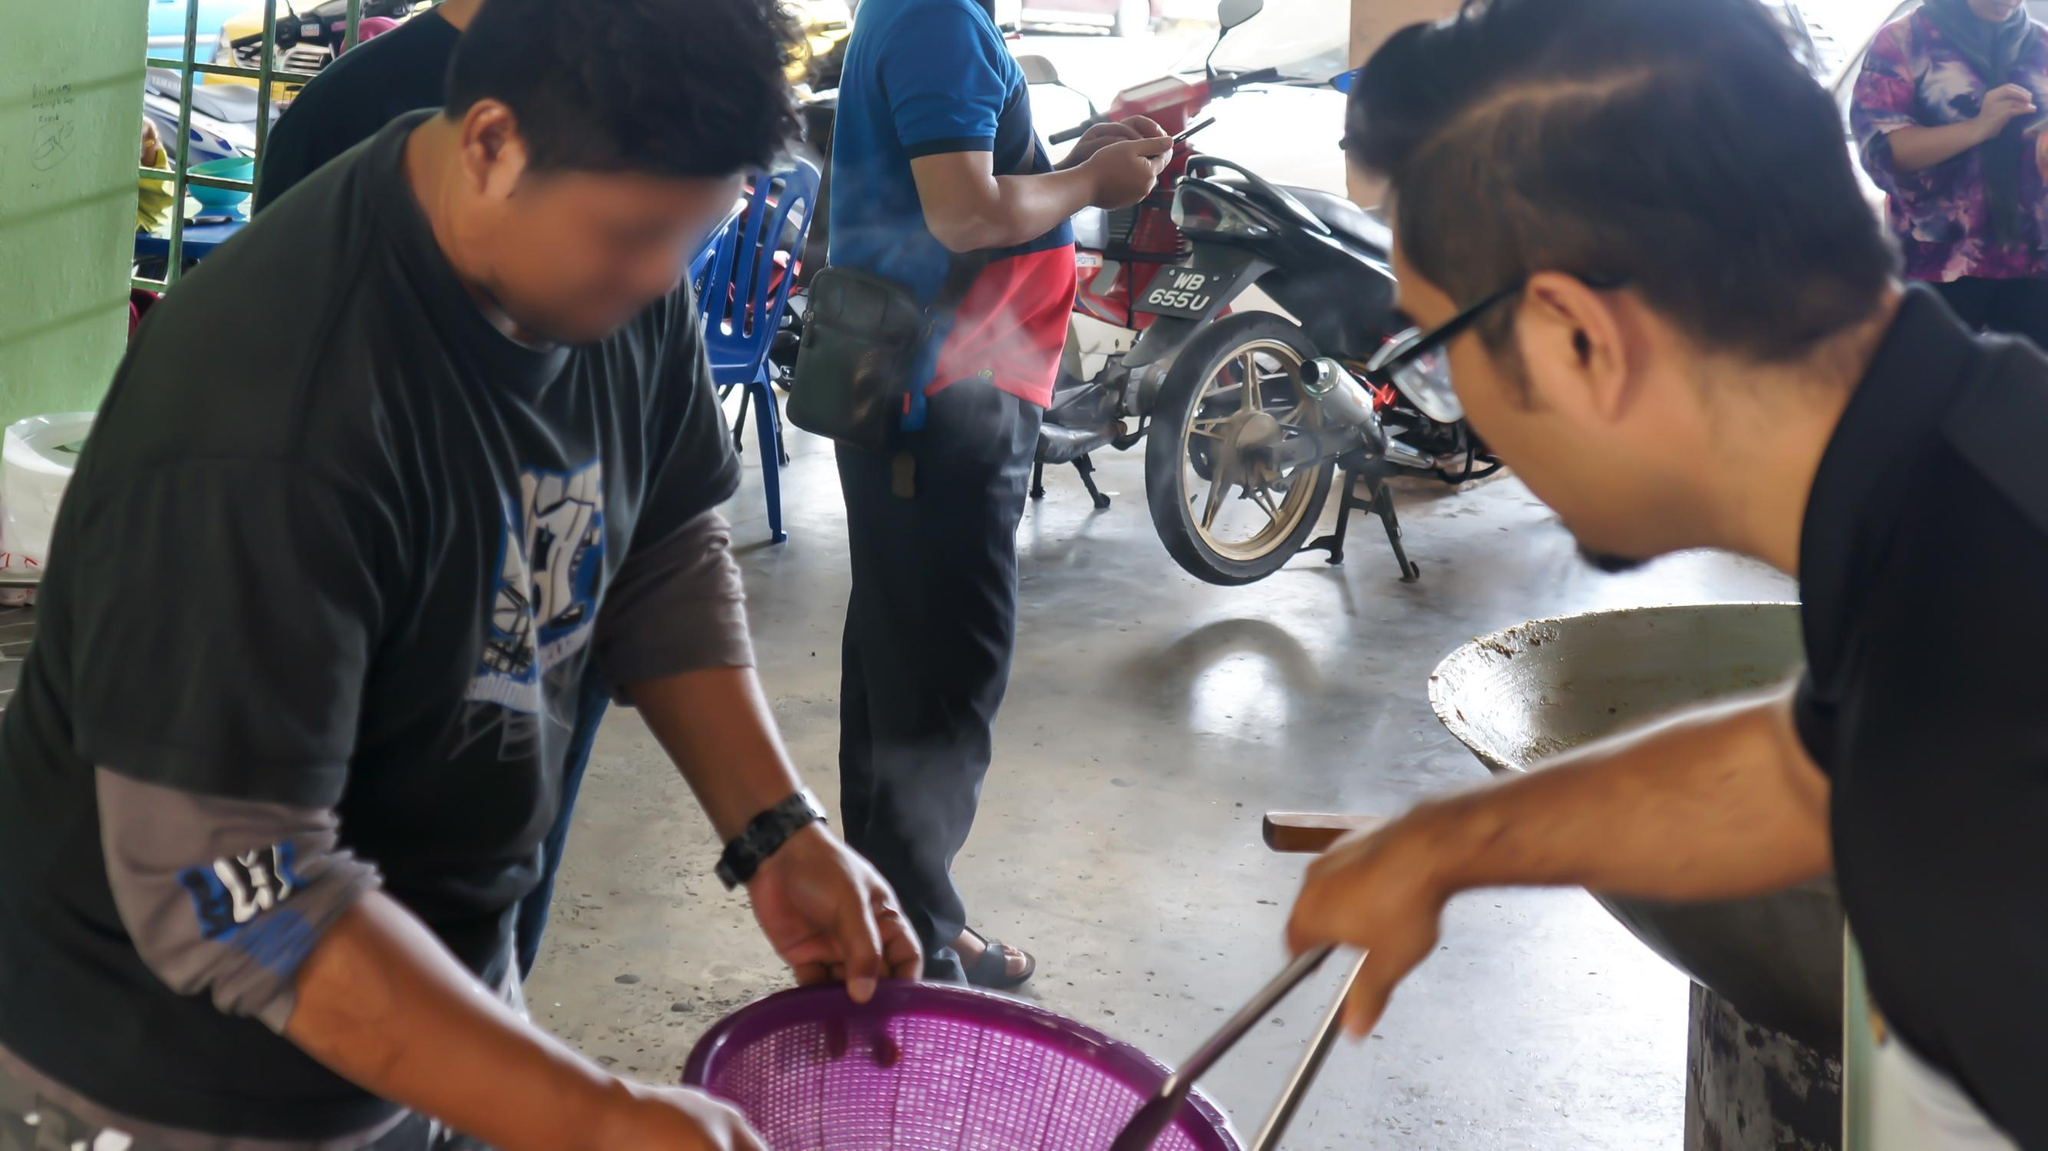Can you describe what the man holding the purple basket might be selling? The image doesn’t provide a clear view of the contents inside the purple basket. However, judging by the focus of the two men and considering common market goods, it's plausible that he might be selling a variety of items, such as fresh produce, handmade goods, or perhaps even street food typical of the region. Without a clearer view, it's difficult to specify exactly what the product is. 